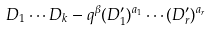Convert formula to latex. <formula><loc_0><loc_0><loc_500><loc_500>D _ { 1 } \cdots D _ { k } - q ^ { \beta } ( D ^ { \prime } _ { 1 } ) ^ { a _ { 1 } } \cdots ( D ^ { \prime } _ { r } ) ^ { a _ { r } }</formula> 